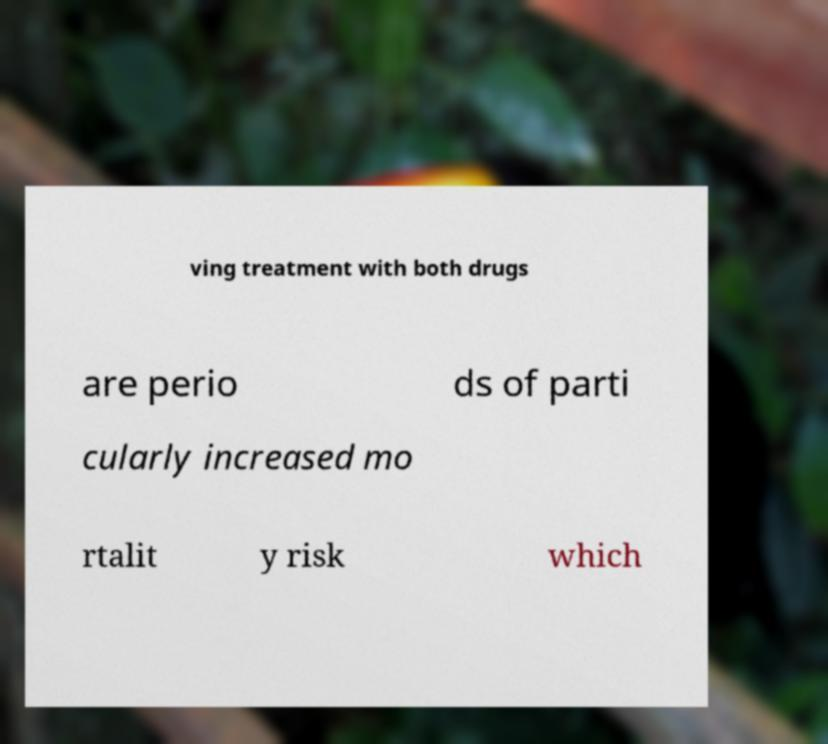Could you assist in decoding the text presented in this image and type it out clearly? ving treatment with both drugs are perio ds of parti cularly increased mo rtalit y risk which 